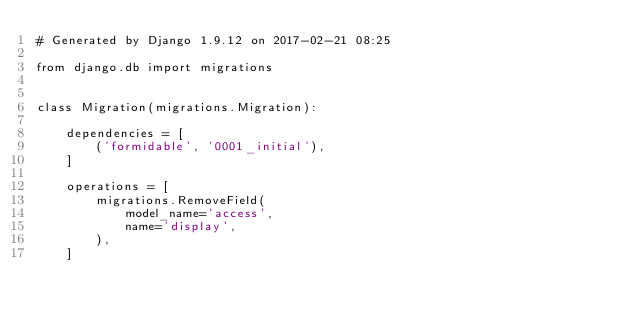<code> <loc_0><loc_0><loc_500><loc_500><_Python_># Generated by Django 1.9.12 on 2017-02-21 08:25

from django.db import migrations


class Migration(migrations.Migration):

    dependencies = [
        ('formidable', '0001_initial'),
    ]

    operations = [
        migrations.RemoveField(
            model_name='access',
            name='display',
        ),
    ]
</code> 